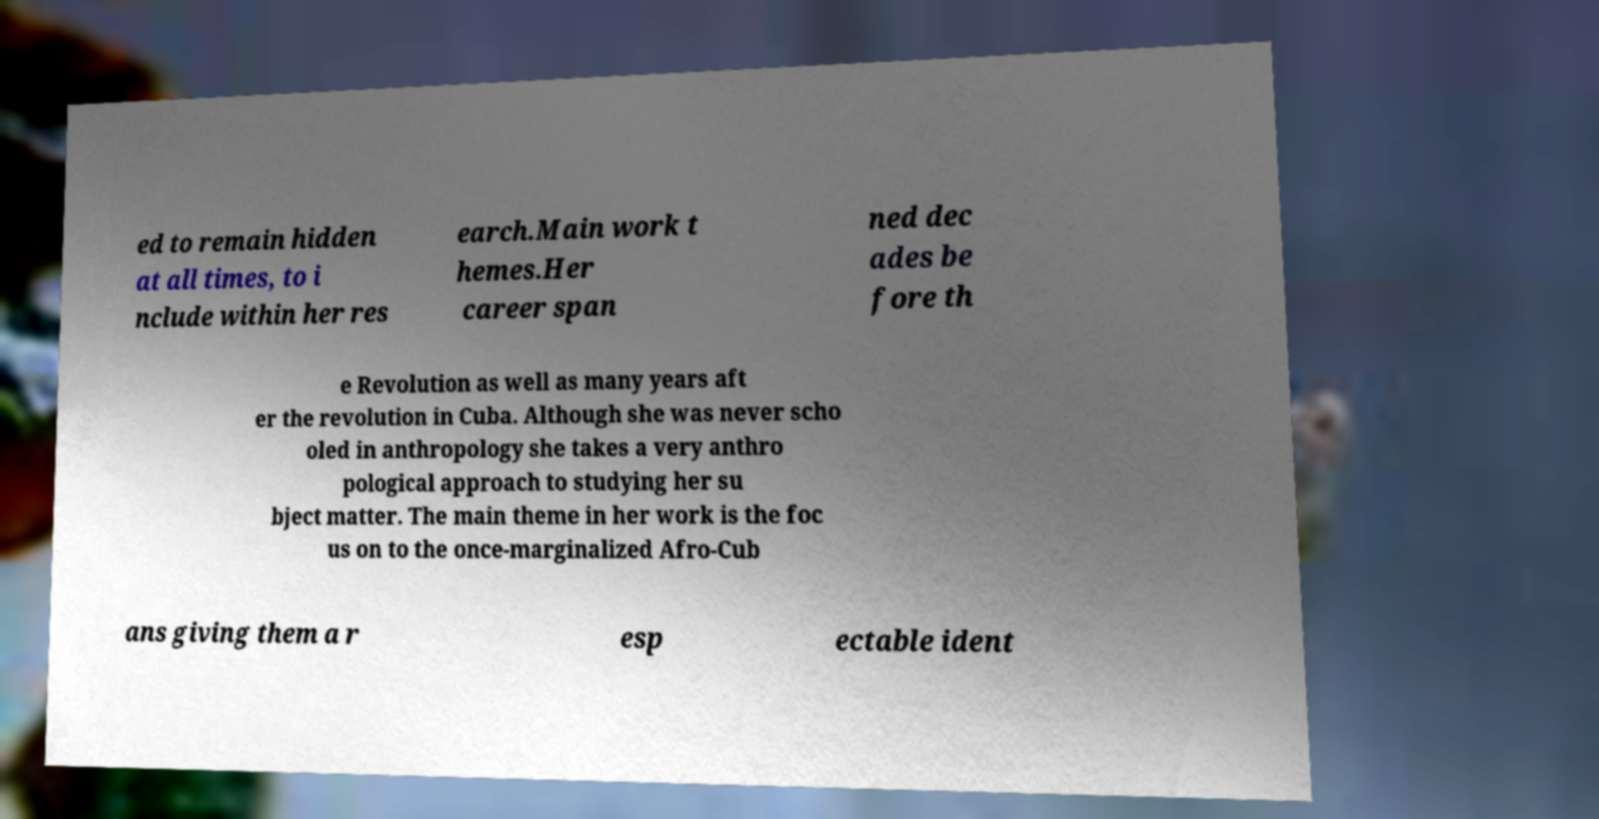Please read and relay the text visible in this image. What does it say? ed to remain hidden at all times, to i nclude within her res earch.Main work t hemes.Her career span ned dec ades be fore th e Revolution as well as many years aft er the revolution in Cuba. Although she was never scho oled in anthropology she takes a very anthro pological approach to studying her su bject matter. The main theme in her work is the foc us on to the once-marginalized Afro-Cub ans giving them a r esp ectable ident 